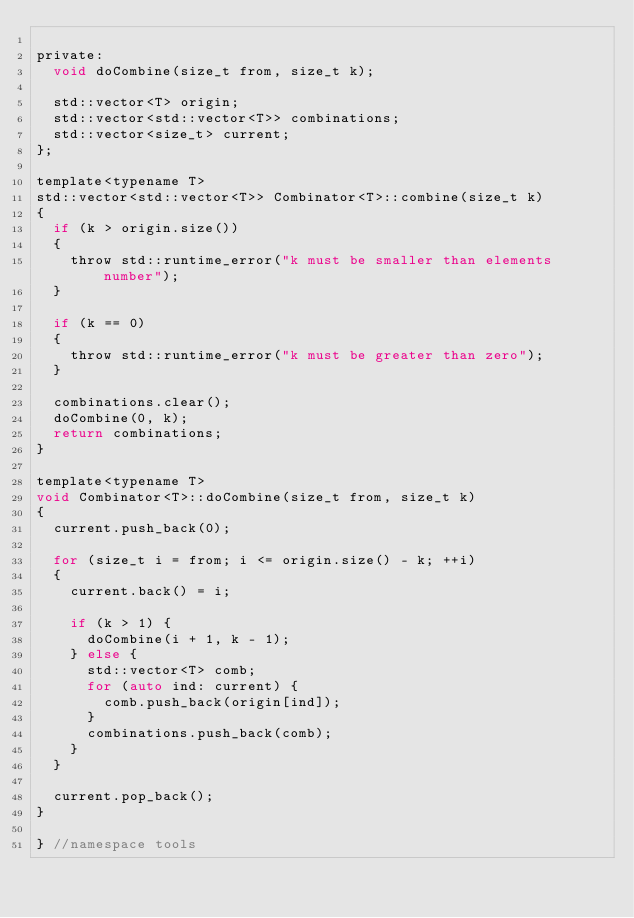Convert code to text. <code><loc_0><loc_0><loc_500><loc_500><_C_>
private:
  void doCombine(size_t from, size_t k);

  std::vector<T> origin;
  std::vector<std::vector<T>> combinations;
  std::vector<size_t> current;
};

template<typename T>
std::vector<std::vector<T>> Combinator<T>::combine(size_t k)
{
  if (k > origin.size())
  {
    throw std::runtime_error("k must be smaller than elements number");
  }

  if (k == 0)
  {
    throw std::runtime_error("k must be greater than zero");
  }

  combinations.clear();
  doCombine(0, k);
  return combinations;
}

template<typename T>
void Combinator<T>::doCombine(size_t from, size_t k)
{
  current.push_back(0);

  for (size_t i = from; i <= origin.size() - k; ++i)
  {
    current.back() = i;

    if (k > 1) {
      doCombine(i + 1, k - 1);
    } else {
      std::vector<T> comb;
      for (auto ind: current) {
        comb.push_back(origin[ind]);
      }
      combinations.push_back(comb);
    }
  }

  current.pop_back();
}

} //namespace tools
</code> 